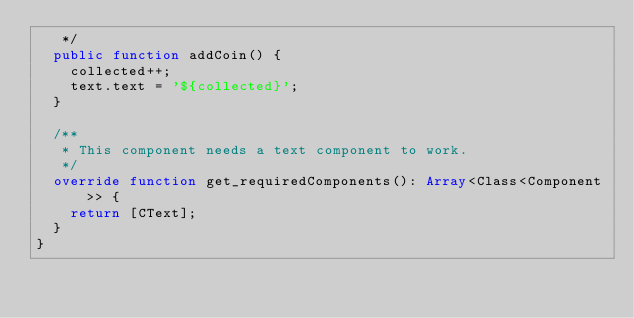<code> <loc_0><loc_0><loc_500><loc_500><_Haxe_>   */
  public function addCoin() {
    collected++;
    text.text = '${collected}';
  }

  /**
   * This component needs a text component to work.
   */
  override function get_requiredComponents(): Array<Class<Component>> {
    return [CText];
  }
}
</code> 